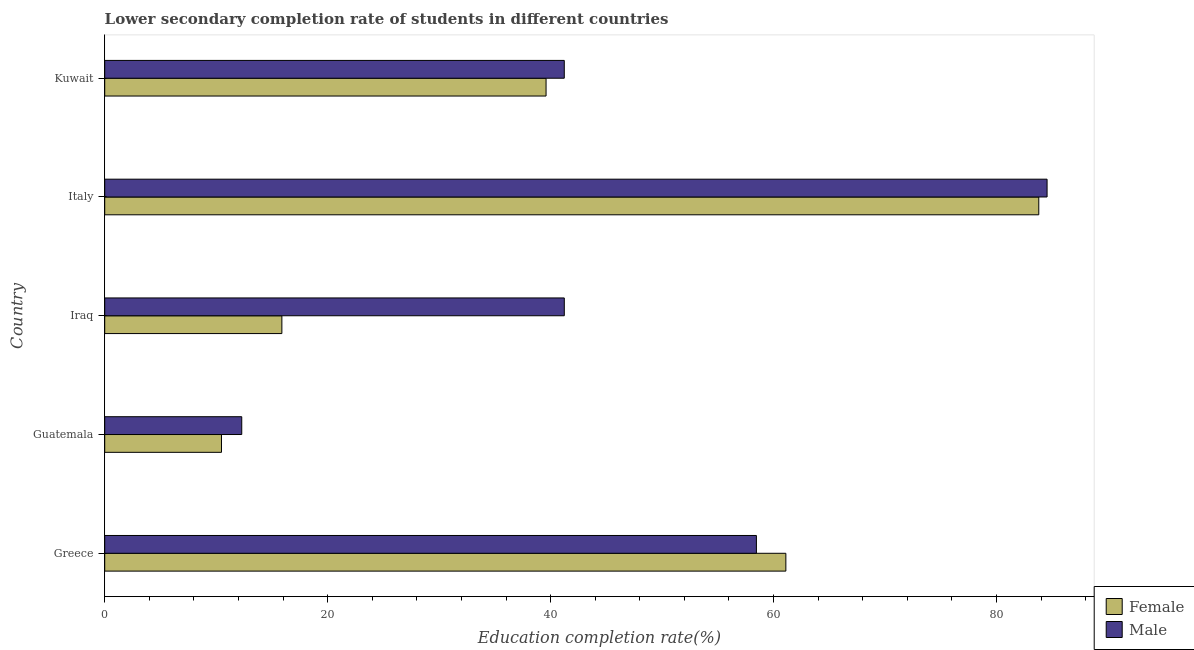How many different coloured bars are there?
Offer a very short reply. 2. How many bars are there on the 1st tick from the top?
Keep it short and to the point. 2. What is the label of the 5th group of bars from the top?
Provide a succinct answer. Greece. In how many cases, is the number of bars for a given country not equal to the number of legend labels?
Make the answer very short. 0. What is the education completion rate of male students in Greece?
Make the answer very short. 58.46. Across all countries, what is the maximum education completion rate of male students?
Keep it short and to the point. 84.54. Across all countries, what is the minimum education completion rate of male students?
Provide a succinct answer. 12.29. In which country was the education completion rate of female students minimum?
Keep it short and to the point. Guatemala. What is the total education completion rate of male students in the graph?
Offer a very short reply. 237.75. What is the difference between the education completion rate of male students in Iraq and that in Italy?
Offer a terse response. -43.31. What is the difference between the education completion rate of female students in Kuwait and the education completion rate of male students in Italy?
Your response must be concise. -44.94. What is the average education completion rate of male students per country?
Your answer should be very brief. 47.55. What is the difference between the education completion rate of female students and education completion rate of male students in Guatemala?
Your response must be concise. -1.82. What is the ratio of the education completion rate of male students in Greece to that in Iraq?
Your answer should be very brief. 1.42. What is the difference between the highest and the second highest education completion rate of female students?
Your answer should be very brief. 22.69. What is the difference between the highest and the lowest education completion rate of male students?
Make the answer very short. 72.24. What does the 1st bar from the bottom in Greece represents?
Your answer should be very brief. Female. How many bars are there?
Your answer should be very brief. 10. What is the difference between two consecutive major ticks on the X-axis?
Provide a short and direct response. 20. Are the values on the major ticks of X-axis written in scientific E-notation?
Make the answer very short. No. Does the graph contain any zero values?
Give a very brief answer. No. Where does the legend appear in the graph?
Your response must be concise. Bottom right. What is the title of the graph?
Your answer should be very brief. Lower secondary completion rate of students in different countries. What is the label or title of the X-axis?
Offer a very short reply. Education completion rate(%). What is the Education completion rate(%) in Female in Greece?
Provide a short and direct response. 61.1. What is the Education completion rate(%) in Male in Greece?
Offer a terse response. 58.46. What is the Education completion rate(%) of Female in Guatemala?
Offer a very short reply. 10.47. What is the Education completion rate(%) of Male in Guatemala?
Give a very brief answer. 12.29. What is the Education completion rate(%) of Female in Iraq?
Ensure brevity in your answer.  15.89. What is the Education completion rate(%) in Male in Iraq?
Keep it short and to the point. 41.23. What is the Education completion rate(%) of Female in Italy?
Make the answer very short. 83.79. What is the Education completion rate(%) of Male in Italy?
Offer a terse response. 84.54. What is the Education completion rate(%) in Female in Kuwait?
Offer a terse response. 39.59. What is the Education completion rate(%) in Male in Kuwait?
Make the answer very short. 41.23. Across all countries, what is the maximum Education completion rate(%) of Female?
Your response must be concise. 83.79. Across all countries, what is the maximum Education completion rate(%) of Male?
Your answer should be very brief. 84.54. Across all countries, what is the minimum Education completion rate(%) of Female?
Make the answer very short. 10.47. Across all countries, what is the minimum Education completion rate(%) of Male?
Provide a short and direct response. 12.29. What is the total Education completion rate(%) of Female in the graph?
Make the answer very short. 210.86. What is the total Education completion rate(%) of Male in the graph?
Offer a terse response. 237.75. What is the difference between the Education completion rate(%) in Female in Greece and that in Guatemala?
Your response must be concise. 50.63. What is the difference between the Education completion rate(%) in Male in Greece and that in Guatemala?
Give a very brief answer. 46.17. What is the difference between the Education completion rate(%) in Female in Greece and that in Iraq?
Your response must be concise. 45.21. What is the difference between the Education completion rate(%) in Male in Greece and that in Iraq?
Keep it short and to the point. 17.23. What is the difference between the Education completion rate(%) in Female in Greece and that in Italy?
Your response must be concise. -22.69. What is the difference between the Education completion rate(%) of Male in Greece and that in Italy?
Your response must be concise. -26.07. What is the difference between the Education completion rate(%) of Female in Greece and that in Kuwait?
Keep it short and to the point. 21.51. What is the difference between the Education completion rate(%) in Male in Greece and that in Kuwait?
Your answer should be very brief. 17.24. What is the difference between the Education completion rate(%) of Female in Guatemala and that in Iraq?
Offer a terse response. -5.42. What is the difference between the Education completion rate(%) in Male in Guatemala and that in Iraq?
Make the answer very short. -28.93. What is the difference between the Education completion rate(%) in Female in Guatemala and that in Italy?
Offer a terse response. -73.32. What is the difference between the Education completion rate(%) of Male in Guatemala and that in Italy?
Your answer should be very brief. -72.24. What is the difference between the Education completion rate(%) of Female in Guatemala and that in Kuwait?
Your answer should be compact. -29.12. What is the difference between the Education completion rate(%) in Male in Guatemala and that in Kuwait?
Your answer should be compact. -28.93. What is the difference between the Education completion rate(%) in Female in Iraq and that in Italy?
Your answer should be compact. -67.9. What is the difference between the Education completion rate(%) in Male in Iraq and that in Italy?
Provide a short and direct response. -43.31. What is the difference between the Education completion rate(%) of Female in Iraq and that in Kuwait?
Offer a very short reply. -23.7. What is the difference between the Education completion rate(%) of Male in Iraq and that in Kuwait?
Keep it short and to the point. 0. What is the difference between the Education completion rate(%) in Female in Italy and that in Kuwait?
Make the answer very short. 44.2. What is the difference between the Education completion rate(%) of Male in Italy and that in Kuwait?
Make the answer very short. 43.31. What is the difference between the Education completion rate(%) of Female in Greece and the Education completion rate(%) of Male in Guatemala?
Provide a succinct answer. 48.81. What is the difference between the Education completion rate(%) of Female in Greece and the Education completion rate(%) of Male in Iraq?
Your response must be concise. 19.88. What is the difference between the Education completion rate(%) of Female in Greece and the Education completion rate(%) of Male in Italy?
Your answer should be very brief. -23.43. What is the difference between the Education completion rate(%) of Female in Greece and the Education completion rate(%) of Male in Kuwait?
Provide a short and direct response. 19.88. What is the difference between the Education completion rate(%) of Female in Guatemala and the Education completion rate(%) of Male in Iraq?
Give a very brief answer. -30.75. What is the difference between the Education completion rate(%) of Female in Guatemala and the Education completion rate(%) of Male in Italy?
Provide a short and direct response. -74.06. What is the difference between the Education completion rate(%) of Female in Guatemala and the Education completion rate(%) of Male in Kuwait?
Provide a succinct answer. -30.75. What is the difference between the Education completion rate(%) in Female in Iraq and the Education completion rate(%) in Male in Italy?
Provide a short and direct response. -68.64. What is the difference between the Education completion rate(%) of Female in Iraq and the Education completion rate(%) of Male in Kuwait?
Your answer should be compact. -25.33. What is the difference between the Education completion rate(%) of Female in Italy and the Education completion rate(%) of Male in Kuwait?
Provide a succinct answer. 42.57. What is the average Education completion rate(%) of Female per country?
Give a very brief answer. 42.17. What is the average Education completion rate(%) of Male per country?
Ensure brevity in your answer.  47.55. What is the difference between the Education completion rate(%) in Female and Education completion rate(%) in Male in Greece?
Ensure brevity in your answer.  2.64. What is the difference between the Education completion rate(%) of Female and Education completion rate(%) of Male in Guatemala?
Your answer should be compact. -1.82. What is the difference between the Education completion rate(%) of Female and Education completion rate(%) of Male in Iraq?
Your answer should be very brief. -25.34. What is the difference between the Education completion rate(%) of Female and Education completion rate(%) of Male in Italy?
Your response must be concise. -0.74. What is the difference between the Education completion rate(%) in Female and Education completion rate(%) in Male in Kuwait?
Ensure brevity in your answer.  -1.63. What is the ratio of the Education completion rate(%) of Female in Greece to that in Guatemala?
Give a very brief answer. 5.83. What is the ratio of the Education completion rate(%) of Male in Greece to that in Guatemala?
Offer a terse response. 4.76. What is the ratio of the Education completion rate(%) in Female in Greece to that in Iraq?
Your response must be concise. 3.84. What is the ratio of the Education completion rate(%) in Male in Greece to that in Iraq?
Your response must be concise. 1.42. What is the ratio of the Education completion rate(%) of Female in Greece to that in Italy?
Your response must be concise. 0.73. What is the ratio of the Education completion rate(%) in Male in Greece to that in Italy?
Make the answer very short. 0.69. What is the ratio of the Education completion rate(%) of Female in Greece to that in Kuwait?
Offer a terse response. 1.54. What is the ratio of the Education completion rate(%) of Male in Greece to that in Kuwait?
Provide a succinct answer. 1.42. What is the ratio of the Education completion rate(%) in Female in Guatemala to that in Iraq?
Provide a succinct answer. 0.66. What is the ratio of the Education completion rate(%) in Male in Guatemala to that in Iraq?
Provide a succinct answer. 0.3. What is the ratio of the Education completion rate(%) in Female in Guatemala to that in Italy?
Offer a very short reply. 0.12. What is the ratio of the Education completion rate(%) of Male in Guatemala to that in Italy?
Your answer should be very brief. 0.15. What is the ratio of the Education completion rate(%) in Female in Guatemala to that in Kuwait?
Provide a succinct answer. 0.26. What is the ratio of the Education completion rate(%) in Male in Guatemala to that in Kuwait?
Provide a succinct answer. 0.3. What is the ratio of the Education completion rate(%) in Female in Iraq to that in Italy?
Offer a terse response. 0.19. What is the ratio of the Education completion rate(%) in Male in Iraq to that in Italy?
Provide a short and direct response. 0.49. What is the ratio of the Education completion rate(%) of Female in Iraq to that in Kuwait?
Give a very brief answer. 0.4. What is the ratio of the Education completion rate(%) of Female in Italy to that in Kuwait?
Give a very brief answer. 2.12. What is the ratio of the Education completion rate(%) of Male in Italy to that in Kuwait?
Your response must be concise. 2.05. What is the difference between the highest and the second highest Education completion rate(%) in Female?
Ensure brevity in your answer.  22.69. What is the difference between the highest and the second highest Education completion rate(%) of Male?
Give a very brief answer. 26.07. What is the difference between the highest and the lowest Education completion rate(%) of Female?
Offer a terse response. 73.32. What is the difference between the highest and the lowest Education completion rate(%) in Male?
Your response must be concise. 72.24. 